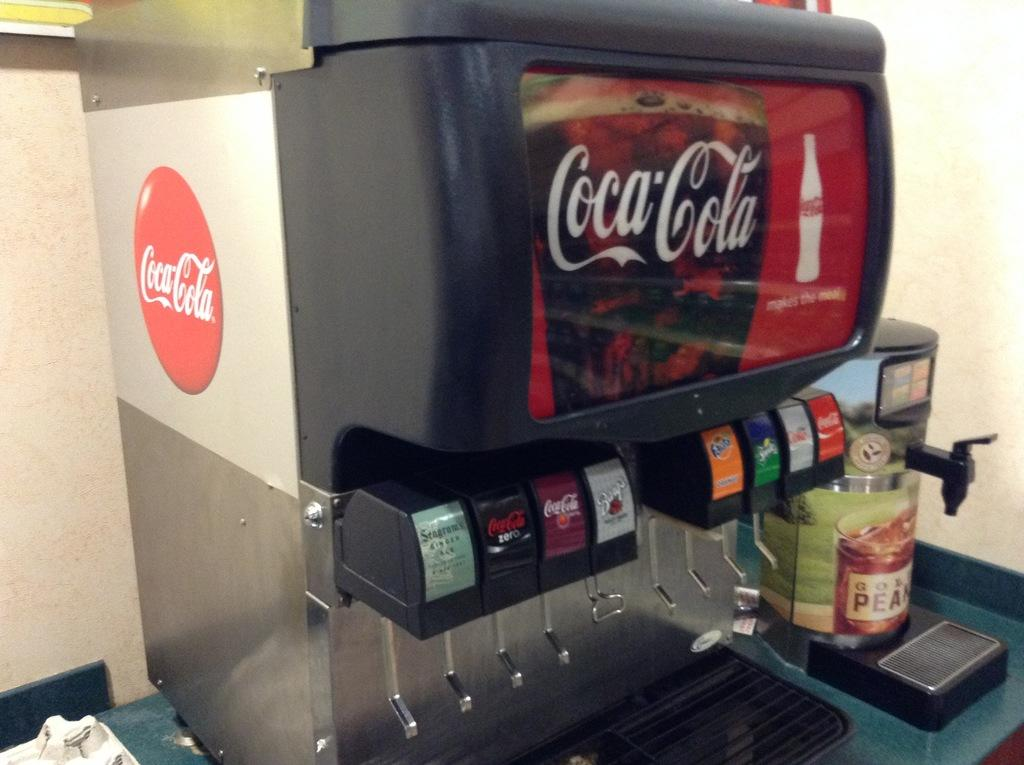<image>
Offer a succinct explanation of the picture presented. A soda fountain features drinks, including Coca-Cola, Fanta, and Sprite. 